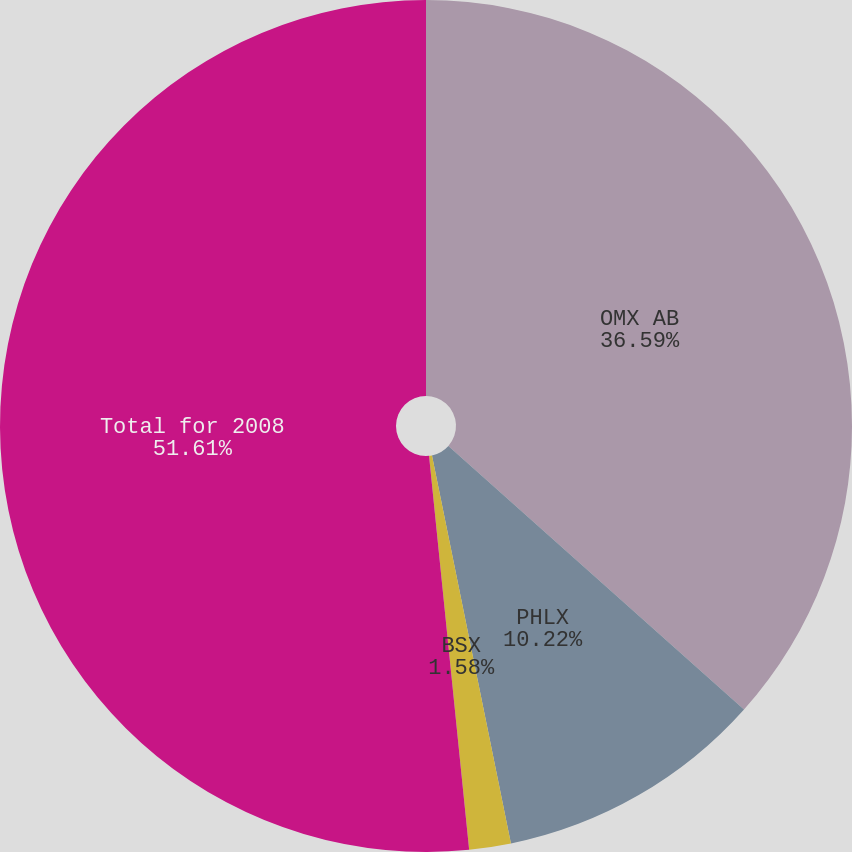<chart> <loc_0><loc_0><loc_500><loc_500><pie_chart><fcel>OMX AB<fcel>PHLX<fcel>BSX<fcel>Total for 2008<nl><fcel>36.59%<fcel>10.22%<fcel>1.58%<fcel>51.62%<nl></chart> 